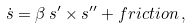Convert formula to latex. <formula><loc_0><loc_0><loc_500><loc_500>\dot { s } = \beta \, s ^ { \prime } \times s ^ { \prime \prime } + f r i c t i o n \, ,</formula> 